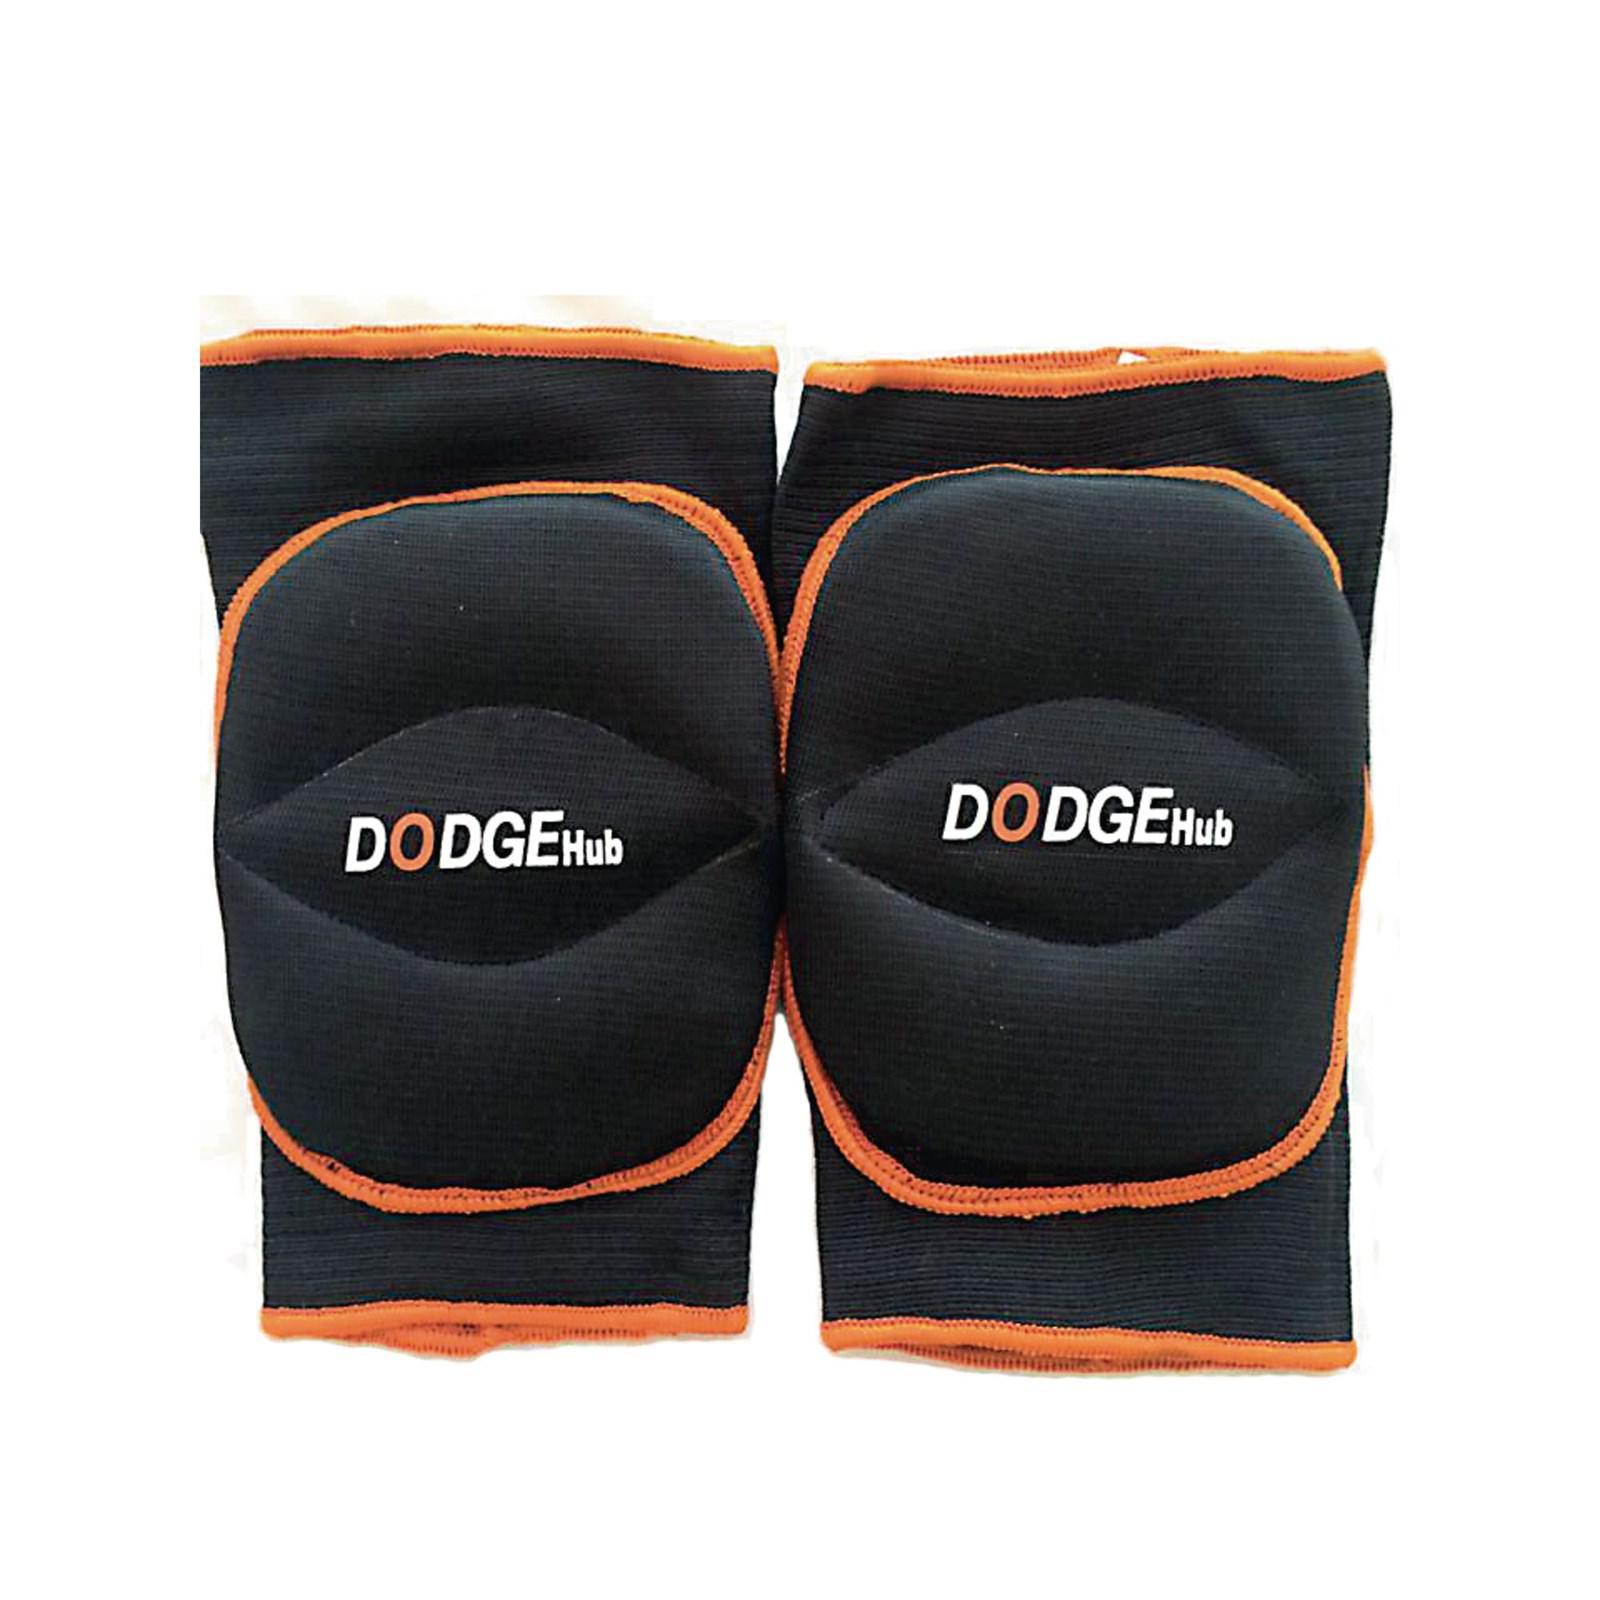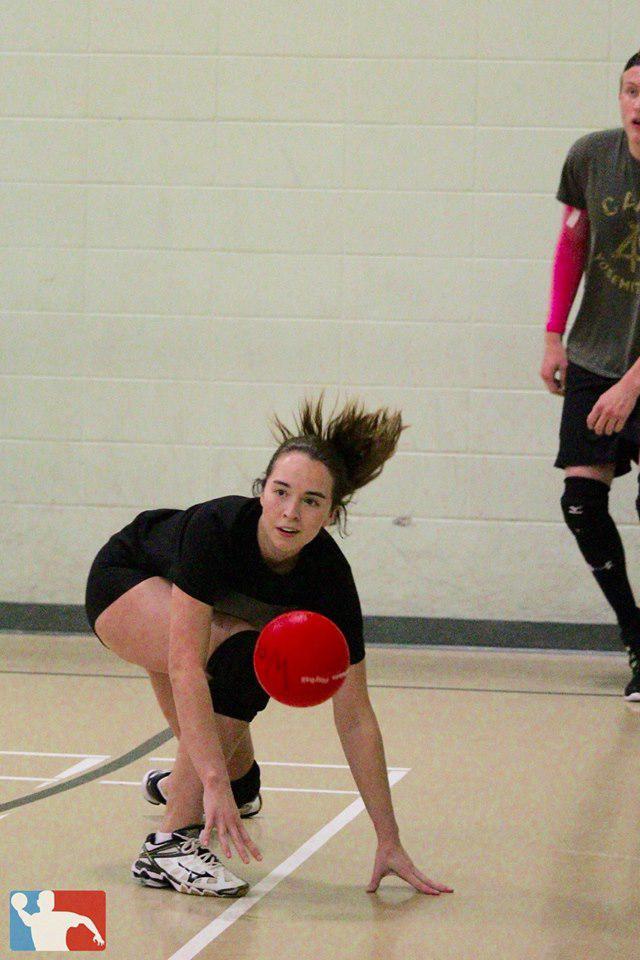The first image is the image on the left, the second image is the image on the right. Examine the images to the left and right. Is the description "The left and right image contains a total of two women playing volleyball." accurate? Answer yes or no. No. The first image is the image on the left, the second image is the image on the right. Given the left and right images, does the statement "One image features an upright girl reaching toward a volleyball with at least one foot off the ground, and the other image features a girl on at least one knee with a volleyball in front of one arm." hold true? Answer yes or no. No. 